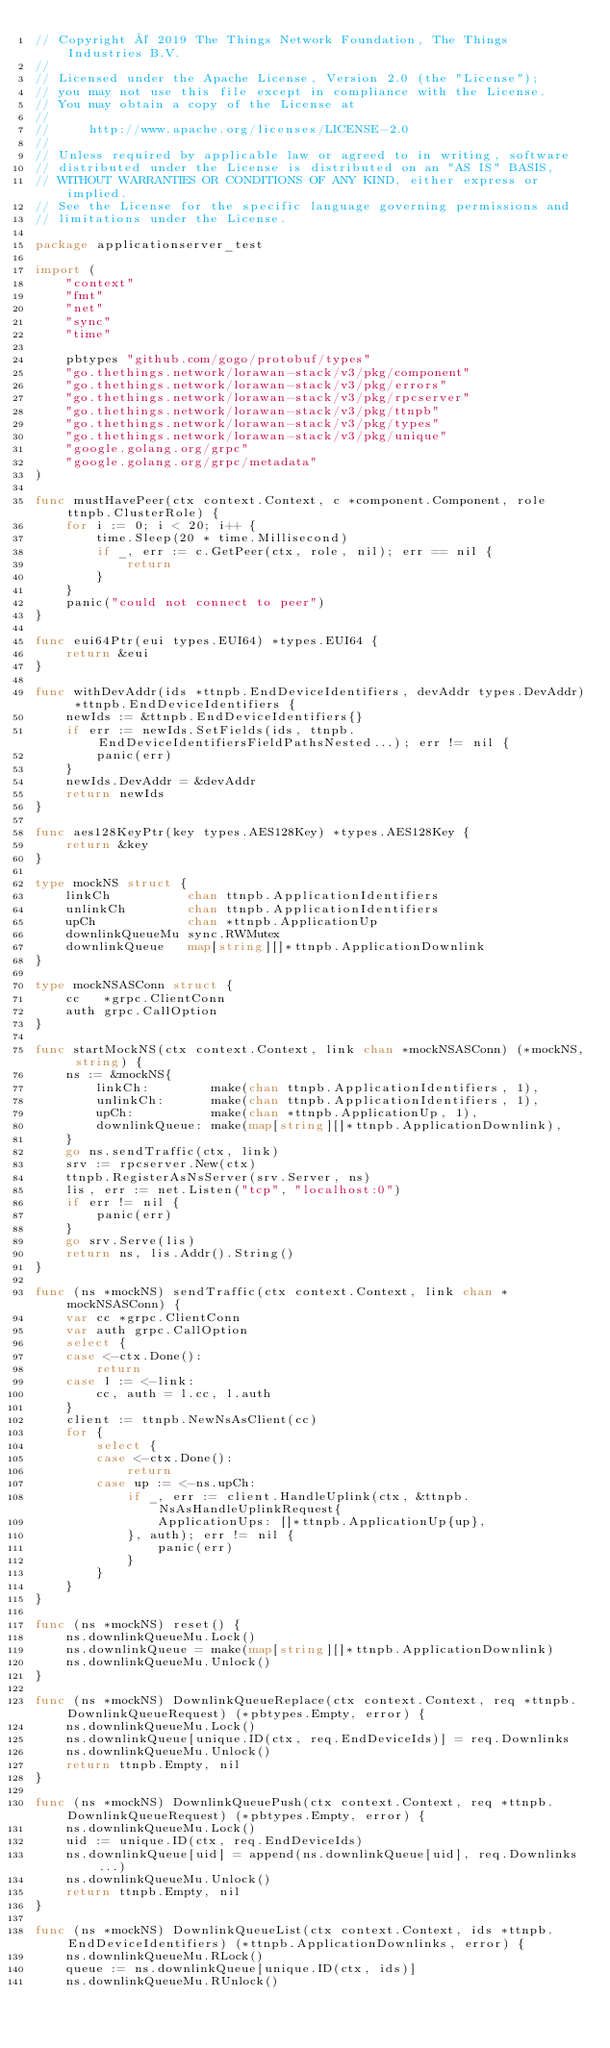<code> <loc_0><loc_0><loc_500><loc_500><_Go_>// Copyright © 2019 The Things Network Foundation, The Things Industries B.V.
//
// Licensed under the Apache License, Version 2.0 (the "License");
// you may not use this file except in compliance with the License.
// You may obtain a copy of the License at
//
//     http://www.apache.org/licenses/LICENSE-2.0
//
// Unless required by applicable law or agreed to in writing, software
// distributed under the License is distributed on an "AS IS" BASIS,
// WITHOUT WARRANTIES OR CONDITIONS OF ANY KIND, either express or implied.
// See the License for the specific language governing permissions and
// limitations under the License.

package applicationserver_test

import (
	"context"
	"fmt"
	"net"
	"sync"
	"time"

	pbtypes "github.com/gogo/protobuf/types"
	"go.thethings.network/lorawan-stack/v3/pkg/component"
	"go.thethings.network/lorawan-stack/v3/pkg/errors"
	"go.thethings.network/lorawan-stack/v3/pkg/rpcserver"
	"go.thethings.network/lorawan-stack/v3/pkg/ttnpb"
	"go.thethings.network/lorawan-stack/v3/pkg/types"
	"go.thethings.network/lorawan-stack/v3/pkg/unique"
	"google.golang.org/grpc"
	"google.golang.org/grpc/metadata"
)

func mustHavePeer(ctx context.Context, c *component.Component, role ttnpb.ClusterRole) {
	for i := 0; i < 20; i++ {
		time.Sleep(20 * time.Millisecond)
		if _, err := c.GetPeer(ctx, role, nil); err == nil {
			return
		}
	}
	panic("could not connect to peer")
}

func eui64Ptr(eui types.EUI64) *types.EUI64 {
	return &eui
}

func withDevAddr(ids *ttnpb.EndDeviceIdentifiers, devAddr types.DevAddr) *ttnpb.EndDeviceIdentifiers {
	newIds := &ttnpb.EndDeviceIdentifiers{}
	if err := newIds.SetFields(ids, ttnpb.EndDeviceIdentifiersFieldPathsNested...); err != nil {
		panic(err)
	}
	newIds.DevAddr = &devAddr
	return newIds
}

func aes128KeyPtr(key types.AES128Key) *types.AES128Key {
	return &key
}

type mockNS struct {
	linkCh          chan ttnpb.ApplicationIdentifiers
	unlinkCh        chan ttnpb.ApplicationIdentifiers
	upCh            chan *ttnpb.ApplicationUp
	downlinkQueueMu sync.RWMutex
	downlinkQueue   map[string][]*ttnpb.ApplicationDownlink
}

type mockNSASConn struct {
	cc   *grpc.ClientConn
	auth grpc.CallOption
}

func startMockNS(ctx context.Context, link chan *mockNSASConn) (*mockNS, string) {
	ns := &mockNS{
		linkCh:        make(chan ttnpb.ApplicationIdentifiers, 1),
		unlinkCh:      make(chan ttnpb.ApplicationIdentifiers, 1),
		upCh:          make(chan *ttnpb.ApplicationUp, 1),
		downlinkQueue: make(map[string][]*ttnpb.ApplicationDownlink),
	}
	go ns.sendTraffic(ctx, link)
	srv := rpcserver.New(ctx)
	ttnpb.RegisterAsNsServer(srv.Server, ns)
	lis, err := net.Listen("tcp", "localhost:0")
	if err != nil {
		panic(err)
	}
	go srv.Serve(lis)
	return ns, lis.Addr().String()
}

func (ns *mockNS) sendTraffic(ctx context.Context, link chan *mockNSASConn) {
	var cc *grpc.ClientConn
	var auth grpc.CallOption
	select {
	case <-ctx.Done():
		return
	case l := <-link:
		cc, auth = l.cc, l.auth
	}
	client := ttnpb.NewNsAsClient(cc)
	for {
		select {
		case <-ctx.Done():
			return
		case up := <-ns.upCh:
			if _, err := client.HandleUplink(ctx, &ttnpb.NsAsHandleUplinkRequest{
				ApplicationUps: []*ttnpb.ApplicationUp{up},
			}, auth); err != nil {
				panic(err)
			}
		}
	}
}

func (ns *mockNS) reset() {
	ns.downlinkQueueMu.Lock()
	ns.downlinkQueue = make(map[string][]*ttnpb.ApplicationDownlink)
	ns.downlinkQueueMu.Unlock()
}

func (ns *mockNS) DownlinkQueueReplace(ctx context.Context, req *ttnpb.DownlinkQueueRequest) (*pbtypes.Empty, error) {
	ns.downlinkQueueMu.Lock()
	ns.downlinkQueue[unique.ID(ctx, req.EndDeviceIds)] = req.Downlinks
	ns.downlinkQueueMu.Unlock()
	return ttnpb.Empty, nil
}

func (ns *mockNS) DownlinkQueuePush(ctx context.Context, req *ttnpb.DownlinkQueueRequest) (*pbtypes.Empty, error) {
	ns.downlinkQueueMu.Lock()
	uid := unique.ID(ctx, req.EndDeviceIds)
	ns.downlinkQueue[uid] = append(ns.downlinkQueue[uid], req.Downlinks...)
	ns.downlinkQueueMu.Unlock()
	return ttnpb.Empty, nil
}

func (ns *mockNS) DownlinkQueueList(ctx context.Context, ids *ttnpb.EndDeviceIdentifiers) (*ttnpb.ApplicationDownlinks, error) {
	ns.downlinkQueueMu.RLock()
	queue := ns.downlinkQueue[unique.ID(ctx, ids)]
	ns.downlinkQueueMu.RUnlock()</code> 